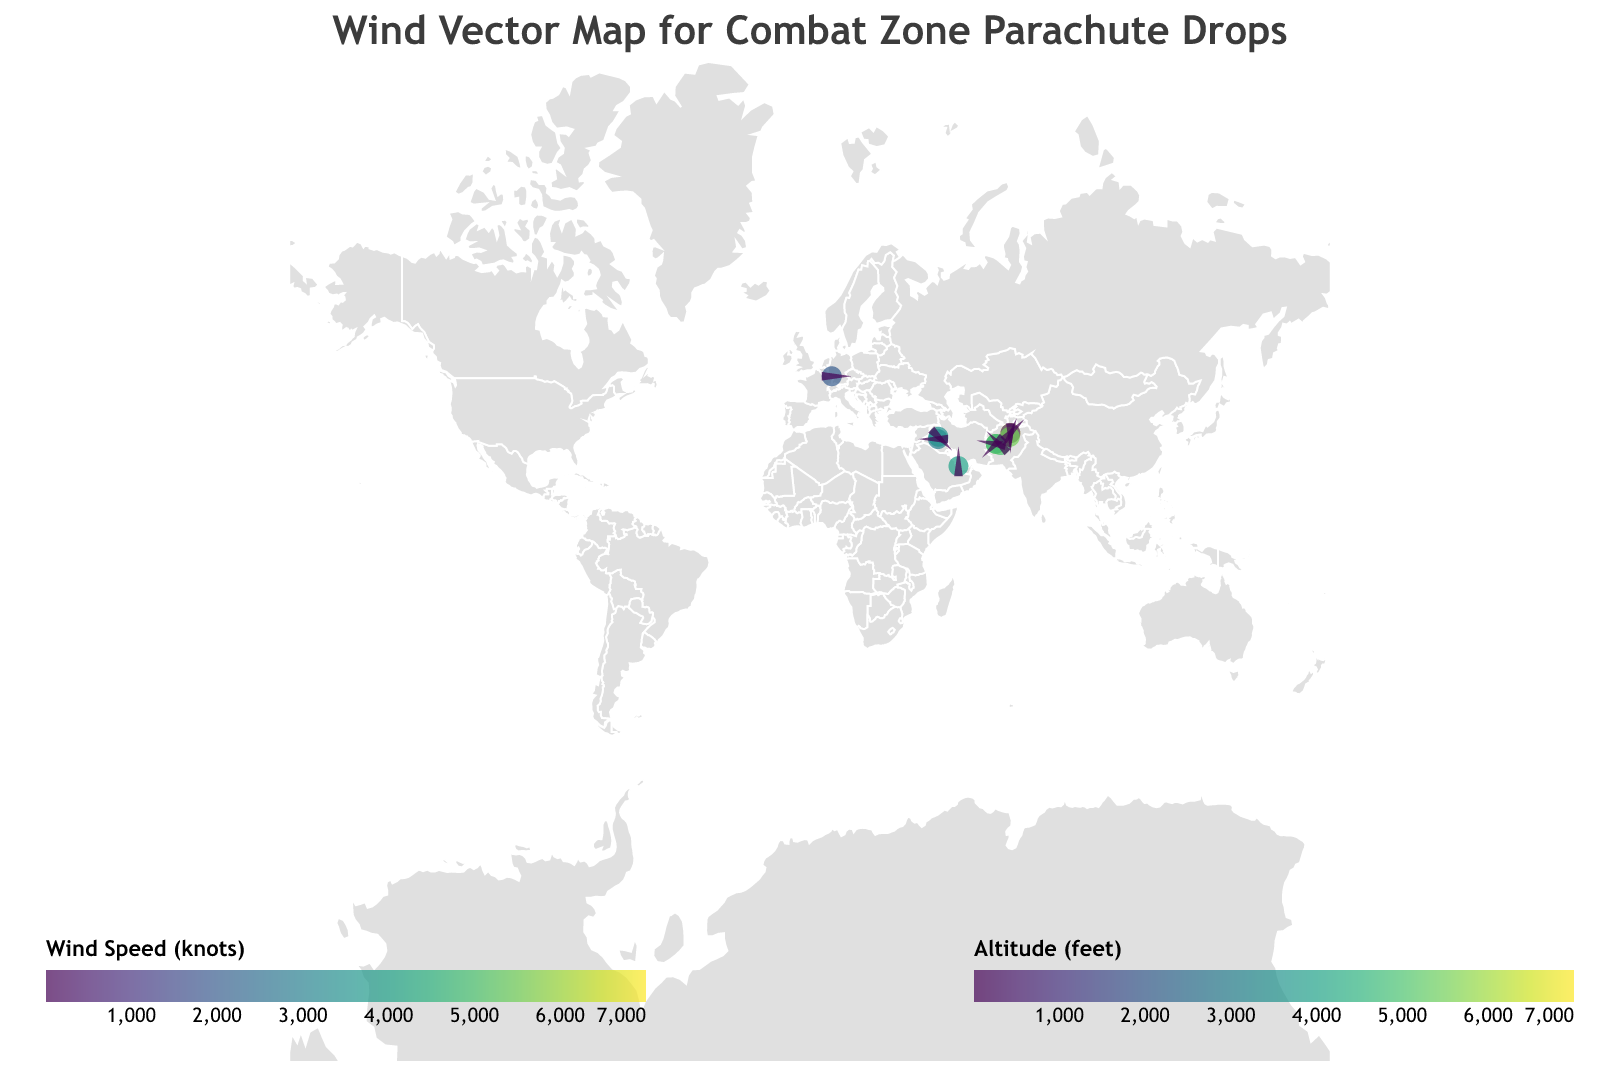Which combat zone has the highest altitude? Look at the color legend for altitude and identify the point with the highest value. Bagam Airfield hits 7000 feet.
Answer: Bagram Airfield Which location has the fastest wind speed? Check the color wheel for wind speed. Camp Leatherneck is the brightest red, indicating 18 knots.
Answer: Camp Leatherneck What is the wind direction at Kandahar Airfield? Refer to the tooltip for Kandahar Airfield. The angle of the wedge shape indicates a wind direction of 135 degrees.
Answer: 135 degrees How does the wind speed at Baghdad International Airport compare to that at Joint Base Balad? Compare the wind speeds in the tooltip for the two locations. Baghdad International Airport has 8 knots, while Joint Base Balad has 9 knots. Joint Base Balad has a higher wind speed.
Answer: Joint Base Balad has higher wind speed What is the average altitude of all locations? Sum the altitudes and divide by the number of locations: (5000 + 3000 + 7000 + 4000 + 2000 + 6000 + 3500 + 1000 + 5500 + 4500)/10 = 41500/10 = 4150 feet.
Answer: 4150 feet Which location has the lowest wind speed? Check the color and tooltip for wind speed. Bagram Airfield's second entry is the lowest at 5 knots.
Answer: Bagram Airfield (1000 feet) How many locations have wind speeds greater than 10 knots? Count the points with a wind speed greater than 10 knots using the tooltip. Locations are: Bagram Airfield (7000 feet), Camp Leatherneck, FOB Shank, and Camp Bastion (4 total).
Answer: 4 locations What is the most common range of wind directions among the locations? Observe the angles of the wedge shapes. Wind directions in the ranges 0-90, 90-180, 180-270, and 270-360 cover the wind directions. The range with the most points is 180-270 degrees with 3 locations (Al Udeid Air Base, FOB Shank, Ramstein Air Base).
Answer: 180-270 degrees 